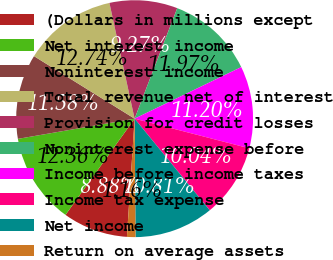Convert chart to OTSL. <chart><loc_0><loc_0><loc_500><loc_500><pie_chart><fcel>(Dollars in millions except<fcel>Net interest income<fcel>Noninterest income<fcel>Total revenue net of interest<fcel>Provision for credit losses<fcel>Noninterest expense before<fcel>Income before income taxes<fcel>Income tax expense<fcel>Net income<fcel>Return on average assets<nl><fcel>8.88%<fcel>12.36%<fcel>11.58%<fcel>12.74%<fcel>9.27%<fcel>11.97%<fcel>11.2%<fcel>10.04%<fcel>10.81%<fcel>1.16%<nl></chart> 